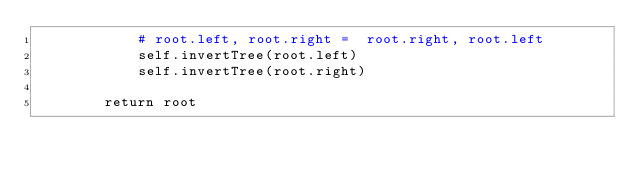<code> <loc_0><loc_0><loc_500><loc_500><_Python_>            # root.left, root.right =  root.right, root.left
            self.invertTree(root.left)
            self.invertTree(root.right)
            
        return root</code> 